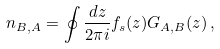<formula> <loc_0><loc_0><loc_500><loc_500>n _ { B , A } = \oint \frac { d z } { 2 \pi i } f _ { s } ( z ) G _ { A , B } ( z ) \, ,</formula> 